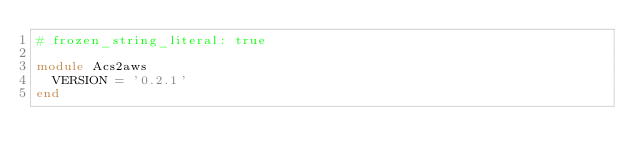Convert code to text. <code><loc_0><loc_0><loc_500><loc_500><_Ruby_># frozen_string_literal: true

module Acs2aws
  VERSION = '0.2.1'
end
</code> 